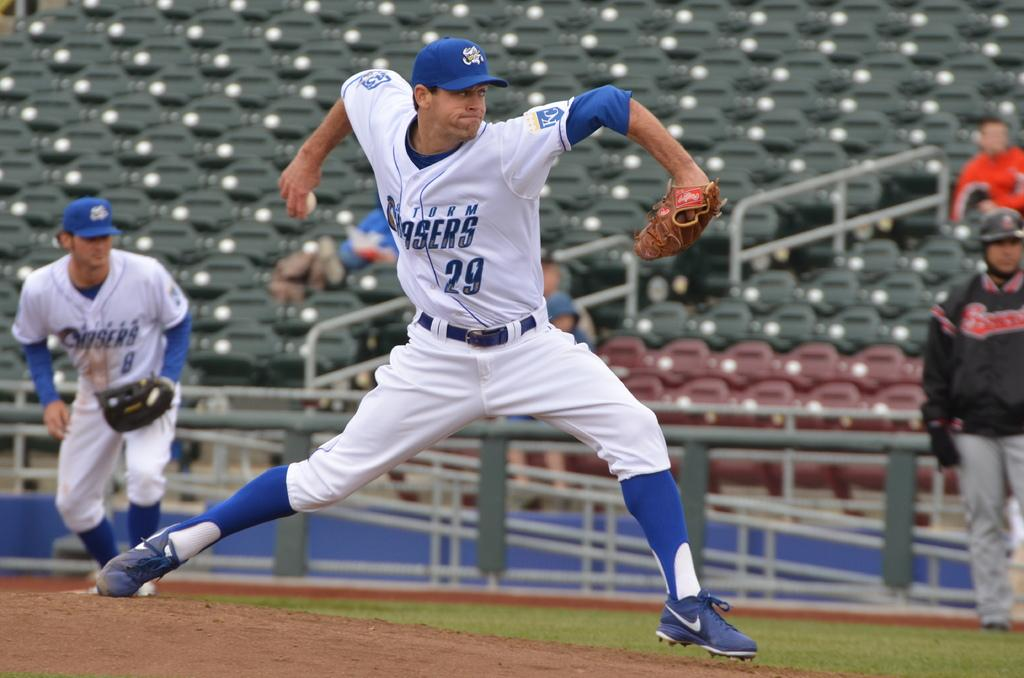<image>
Summarize the visual content of the image. a man in white and blue playing sports wearing a shirt with 29 on it 